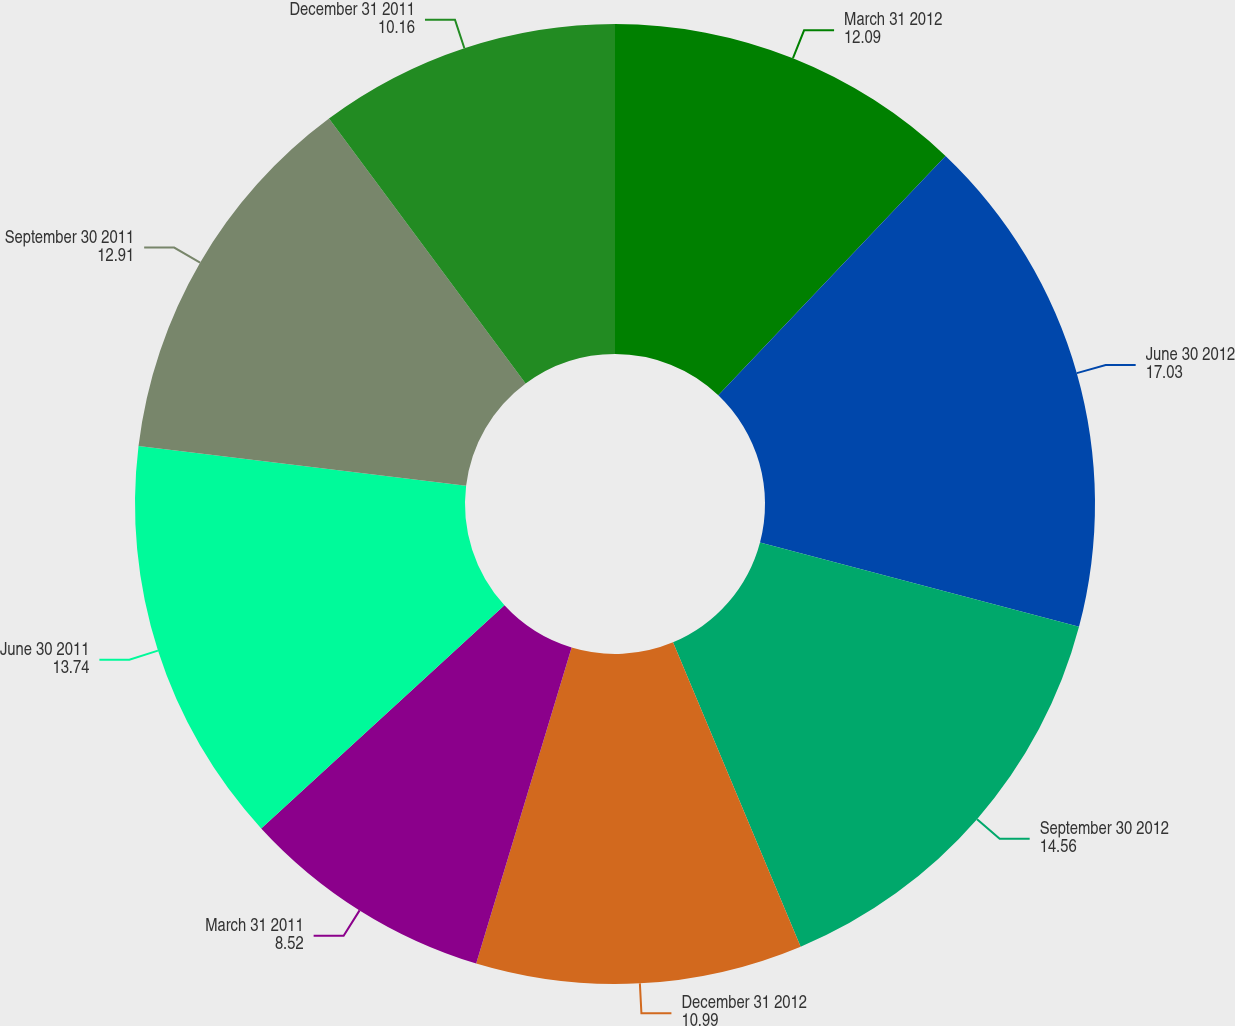Convert chart to OTSL. <chart><loc_0><loc_0><loc_500><loc_500><pie_chart><fcel>March 31 2012<fcel>June 30 2012<fcel>September 30 2012<fcel>December 31 2012<fcel>March 31 2011<fcel>June 30 2011<fcel>September 30 2011<fcel>December 31 2011<nl><fcel>12.09%<fcel>17.03%<fcel>14.56%<fcel>10.99%<fcel>8.52%<fcel>13.74%<fcel>12.91%<fcel>10.16%<nl></chart> 